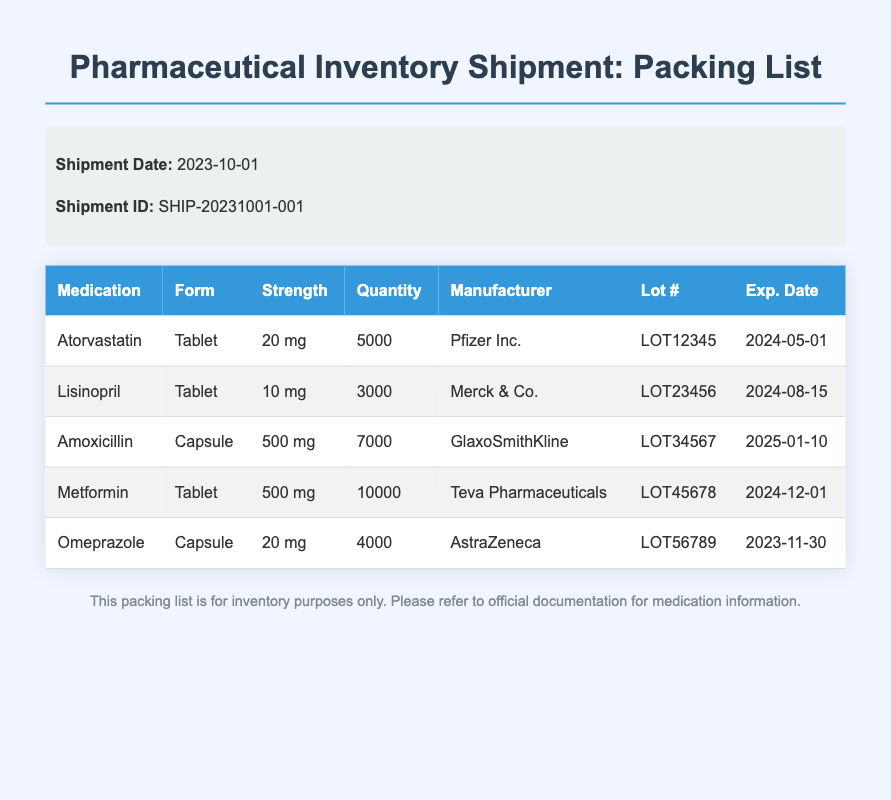What is the shipment date? The shipment date is provided in the shipment information section of the document.
Answer: 2023-10-01 How many tablets of Atorvastatin are included? The quantity of Atorvastatin is listed in the medication table under Quantity.
Answer: 5000 Which manufacturer produces Lisinopril? The manufacturer for Lisinopril is listed in the medication table under Manufacturer.
Answer: Merck & Co What is the expiration date of Omeprazole? The expiration date for Omeprazole is found in the medication table under Exp. Date.
Answer: 2023-11-30 How many total capsules of Amoxicillin are shipped? The total number of Amoxicillin capsules is specified in the Quantity column of the medication table.
Answer: 7000 What is the strength of Metformin? The strength of Metformin is indicated in the Strength column of the medication table.
Answer: 500 mg Which medication has the highest quantity? Comparing the quantities listed in the document, the medication with the highest quantity can be found.
Answer: Metformin What is the lot number for Atorvastatin? The lot number for Atorvastatin is found in the Lot # column of the medication table.
Answer: LOT12345 What document type does this represent? The header of the document clearly defines the type of document it is.
Answer: Packing List 